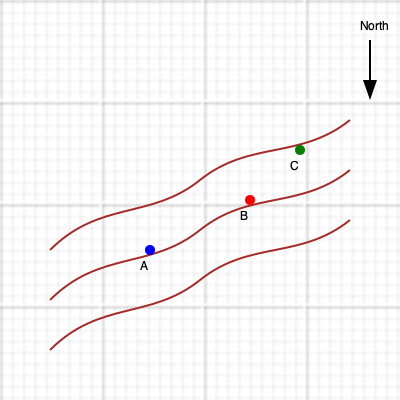Based on the topographical map provided, which location (A, B, or C) would be most suitable for growing crops that require well-drained soils and maximum sunlight exposure? To determine the optimal location for crops requiring well-drained soils and maximum sunlight exposure, we need to analyze the topographical map considering elevation, slope, and aspect:

1. Elevation: The brown contour lines represent elevation, with higher elevations towards the top of the map.
   - A is at the lowest elevation
   - B is at a medium elevation
   - C is at the highest elevation

2. Slope: The spacing between contour lines indicates the steepness of the slope.
   - A has widely spaced contour lines, indicating a gentler slope
   - B has moderately spaced contour lines, indicating a moderate slope
   - C has closely spaced contour lines, indicating a steeper slope

3. Aspect: The direction a slope faces affects sunlight exposure.
   - The map shows a general slope facing south (assuming north is up)
   - C is highest and most exposed, likely receiving the most sunlight
   - B is in the middle, receiving moderate sunlight
   - A is lowest and may receive less direct sunlight due to potential shading from higher elevations

4. Drainage: Well-drained soils are typically found on slopes rather than flat areas.
   - C, being on the steepest slope, would likely have the best drainage
   - B would have moderate drainage
   - A, being on the gentlest slope, may have the poorest drainage

Considering these factors:
- C offers the best drainage and sunlight exposure but may be too steep for easy cultivation
- B provides a good balance of drainage, sunlight, and moderate slope for cultivation
- A may have drainage issues and potentially less sunlight exposure

Therefore, location B would be the most suitable for growing crops that require well-drained soils and maximum sunlight exposure, as it offers a balance of good drainage, adequate sunlight, and a manageable slope for cultivation.
Answer: B 